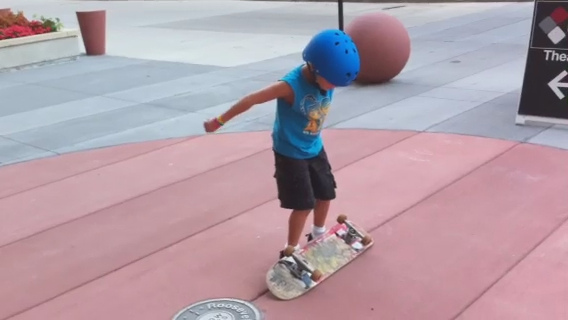Please identify all text content in this image. The 